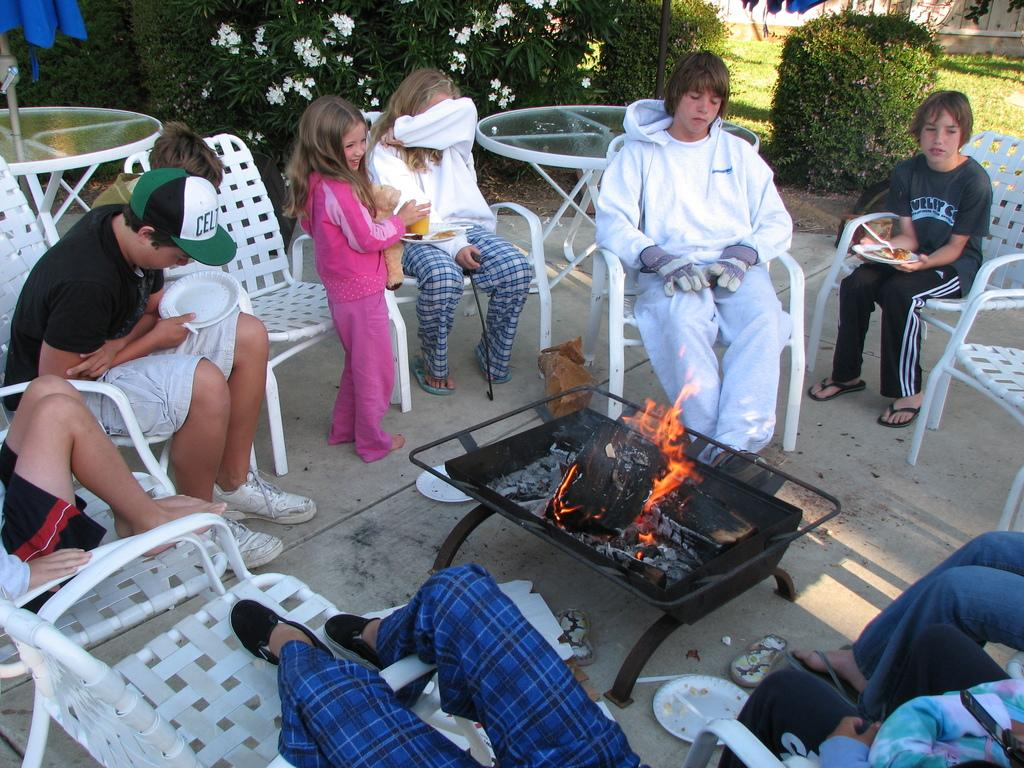<image>
Summarize the visual content of the image. Boy wearing a green and white cap saying CEL eating some food. 